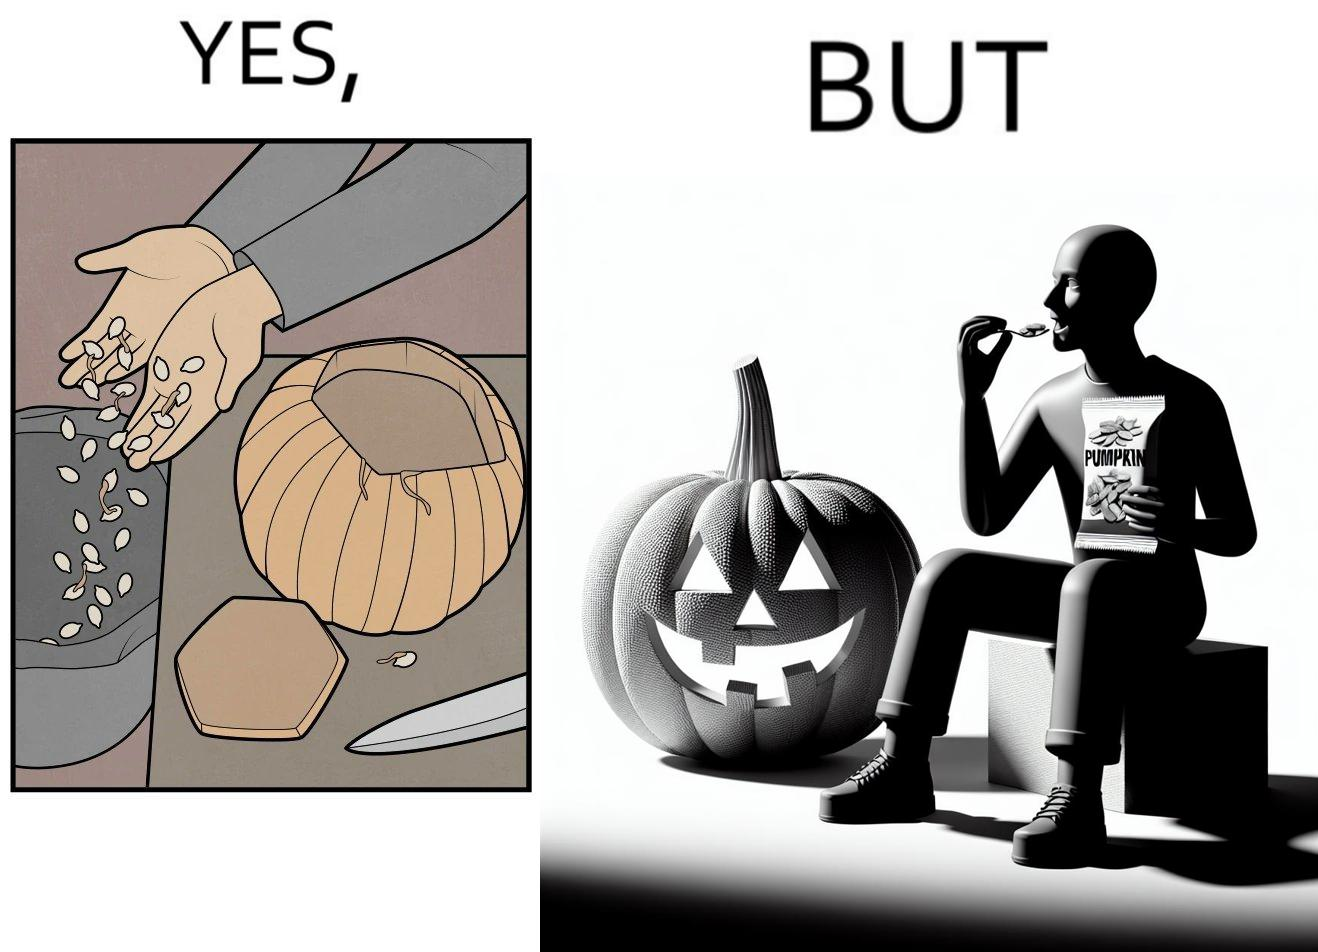Is this a satirical image? Yes, this image is satirical. 